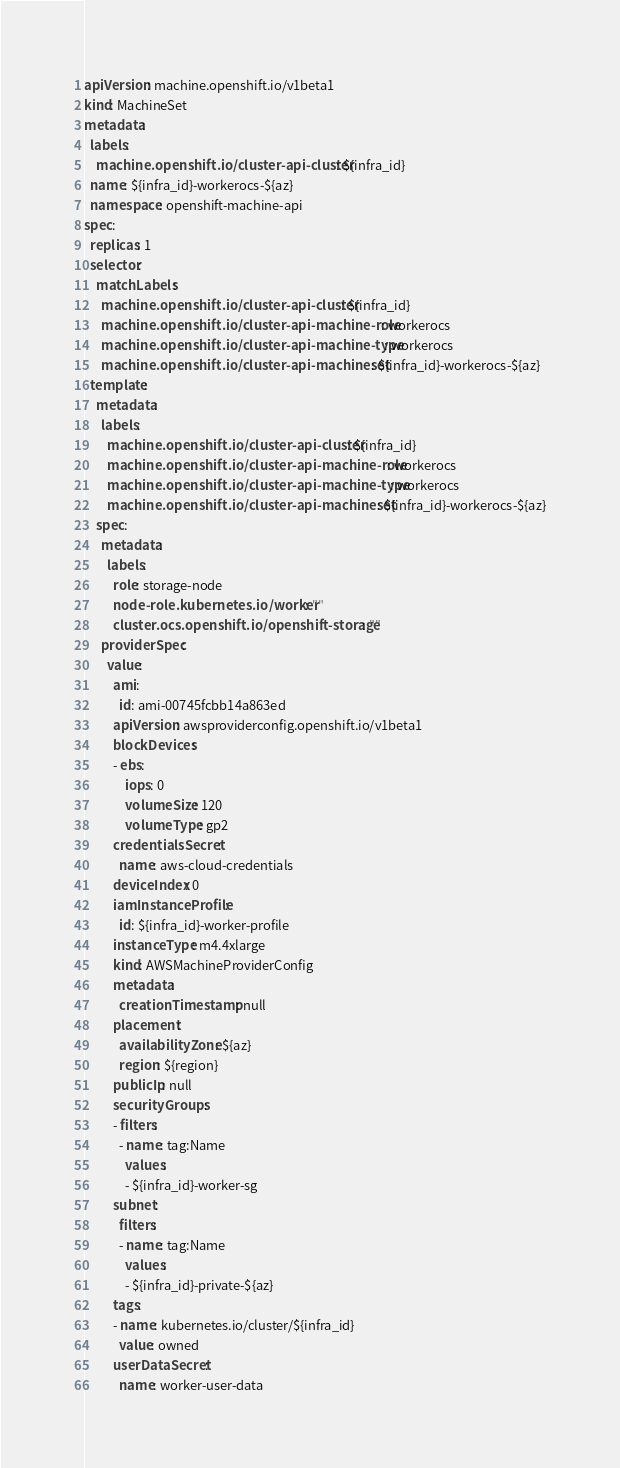<code> <loc_0><loc_0><loc_500><loc_500><_YAML_>apiVersion: machine.openshift.io/v1beta1
kind: MachineSet
metadata:
  labels:
    machine.openshift.io/cluster-api-cluster: ${infra_id}
  name: ${infra_id}-workerocs-${az}
  namespace: openshift-machine-api
spec:
  replicas: 1
  selector:
    matchLabels:
      machine.openshift.io/cluster-api-cluster: ${infra_id}
      machine.openshift.io/cluster-api-machine-role: workerocs
      machine.openshift.io/cluster-api-machine-type: workerocs
      machine.openshift.io/cluster-api-machineset: ${infra_id}-workerocs-${az}
  template:
    metadata:
      labels:
        machine.openshift.io/cluster-api-cluster: ${infra_id}
        machine.openshift.io/cluster-api-machine-role: workerocs
        machine.openshift.io/cluster-api-machine-type: workerocs
        machine.openshift.io/cluster-api-machineset: ${infra_id}-workerocs-${az}
    spec:
      metadata:
        labels:
          role: storage-node
          node-role.kubernetes.io/worker: ""
          cluster.ocs.openshift.io/openshift-storage: ""
      providerSpec:
        value:
          ami:
            id: ami-00745fcbb14a863ed
          apiVersion: awsproviderconfig.openshift.io/v1beta1
          blockDevices:
          - ebs:
              iops: 0
              volumeSize: 120
              volumeType: gp2               
          credentialsSecret:
            name: aws-cloud-credentials
          deviceIndex: 0
          iamInstanceProfile:
            id: ${infra_id}-worker-profile
          instanceType: m4.4xlarge
          kind: AWSMachineProviderConfig
          metadata:
            creationTimestamp: null
          placement:
            availabilityZone: ${az}
            region: ${region}
          publicIp: null
          securityGroups:
          - filters:
            - name: tag:Name
              values:
              - ${infra_id}-worker-sg
          subnet:
            filters:
            - name: tag:Name
              values:
              - ${infra_id}-private-${az}
          tags:
          - name: kubernetes.io/cluster/${infra_id}
            value: owned
          userDataSecret:
            name: worker-user-data</code> 